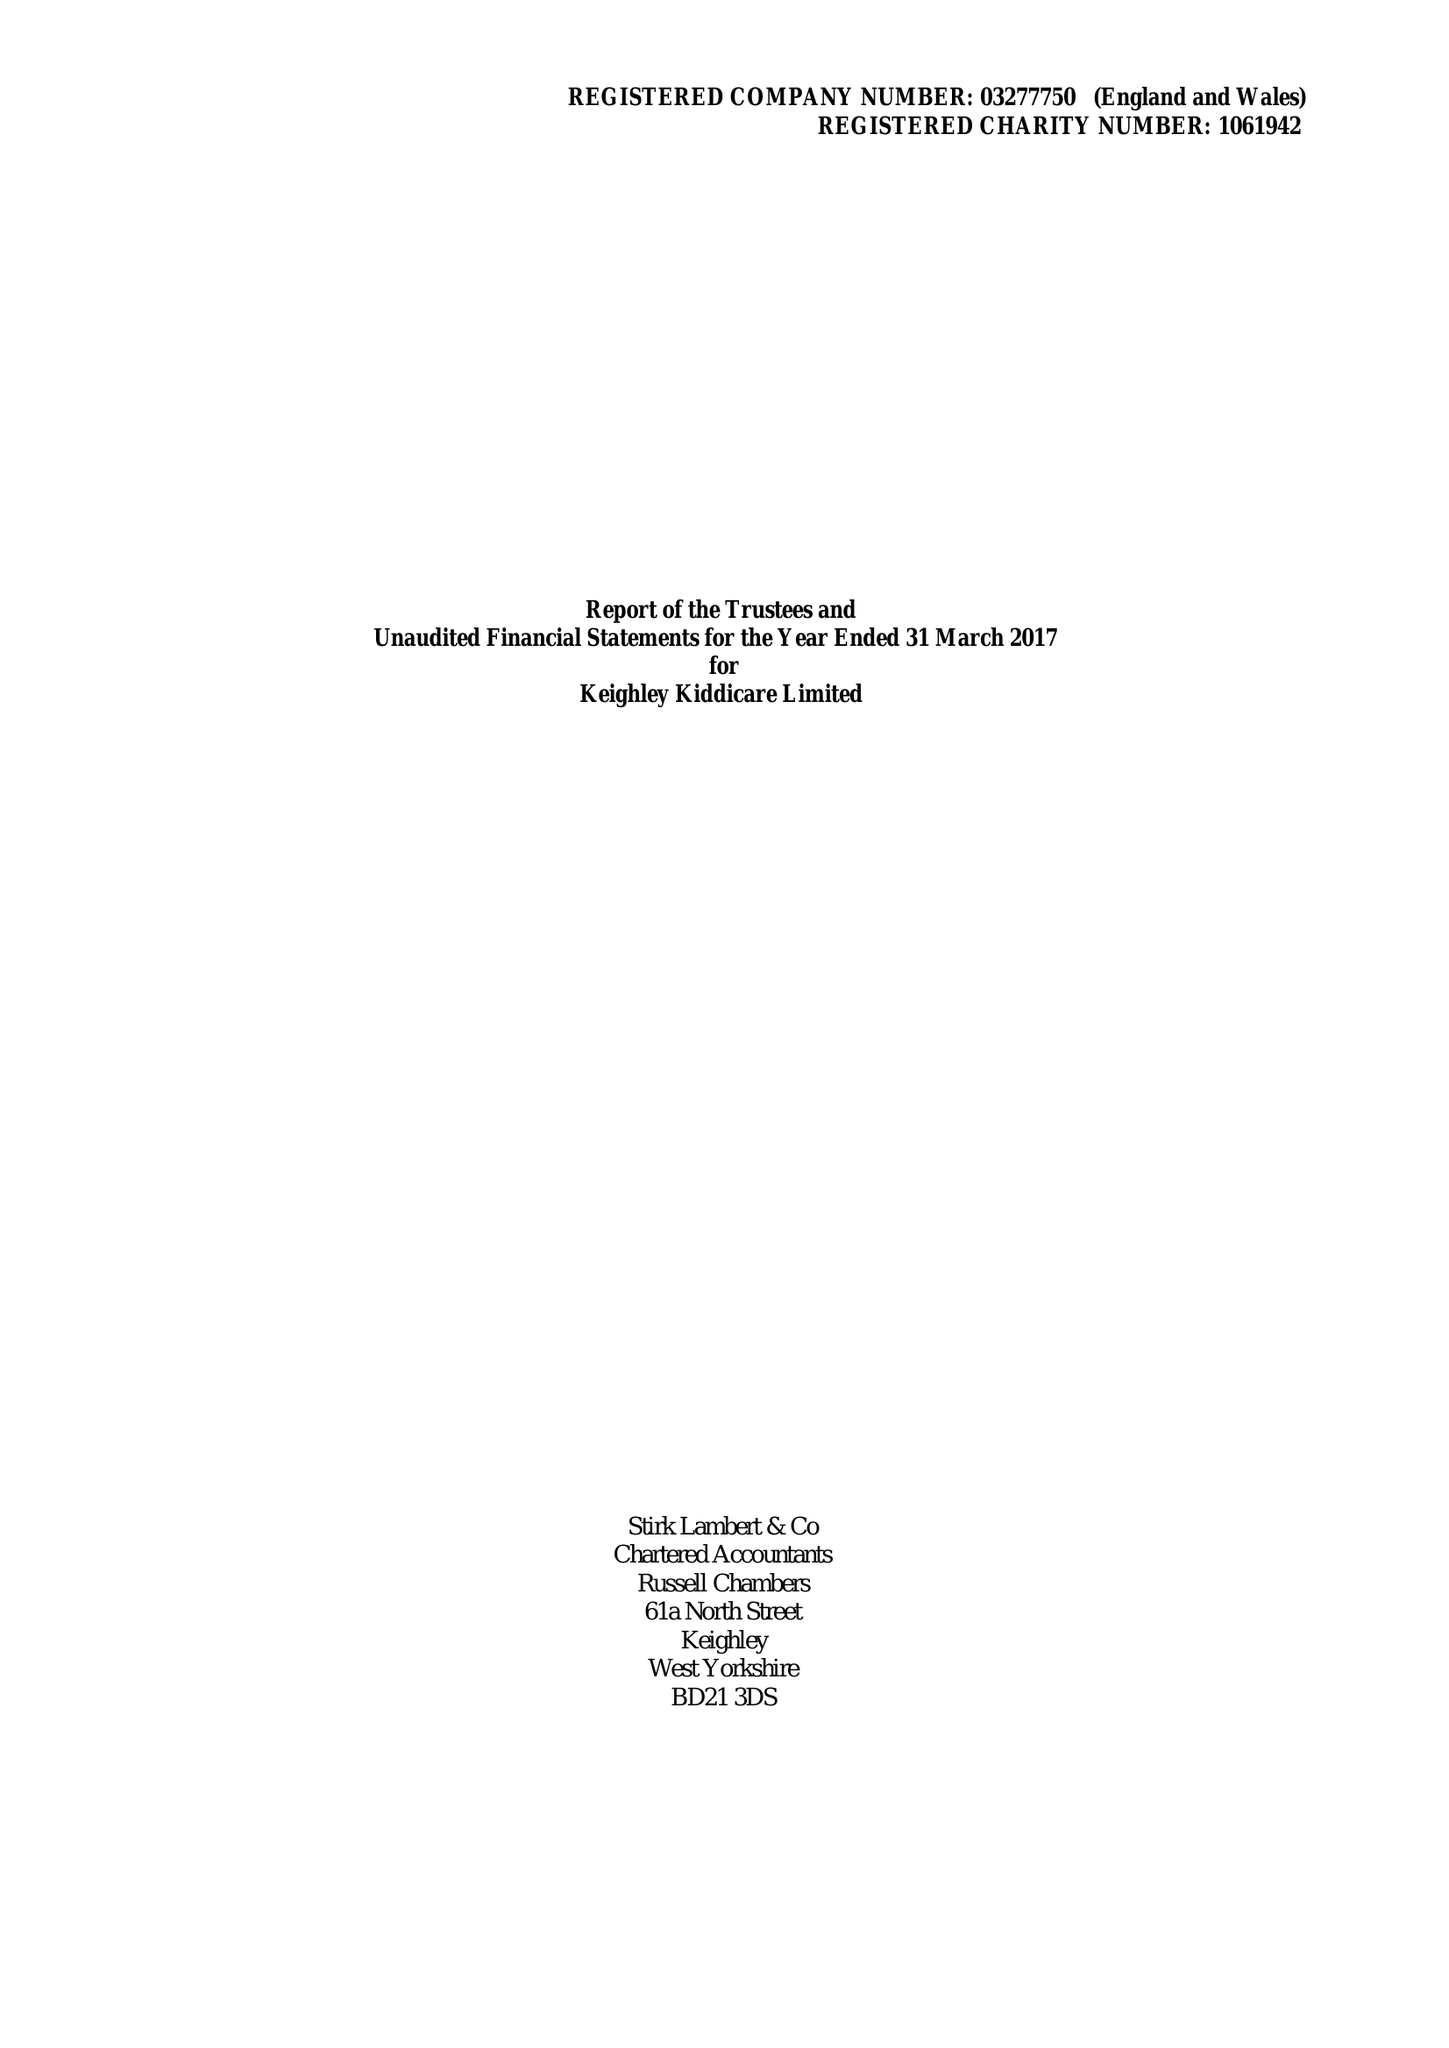What is the value for the address__street_line?
Answer the question using a single word or phrase. 33 BARLOW ROAD 